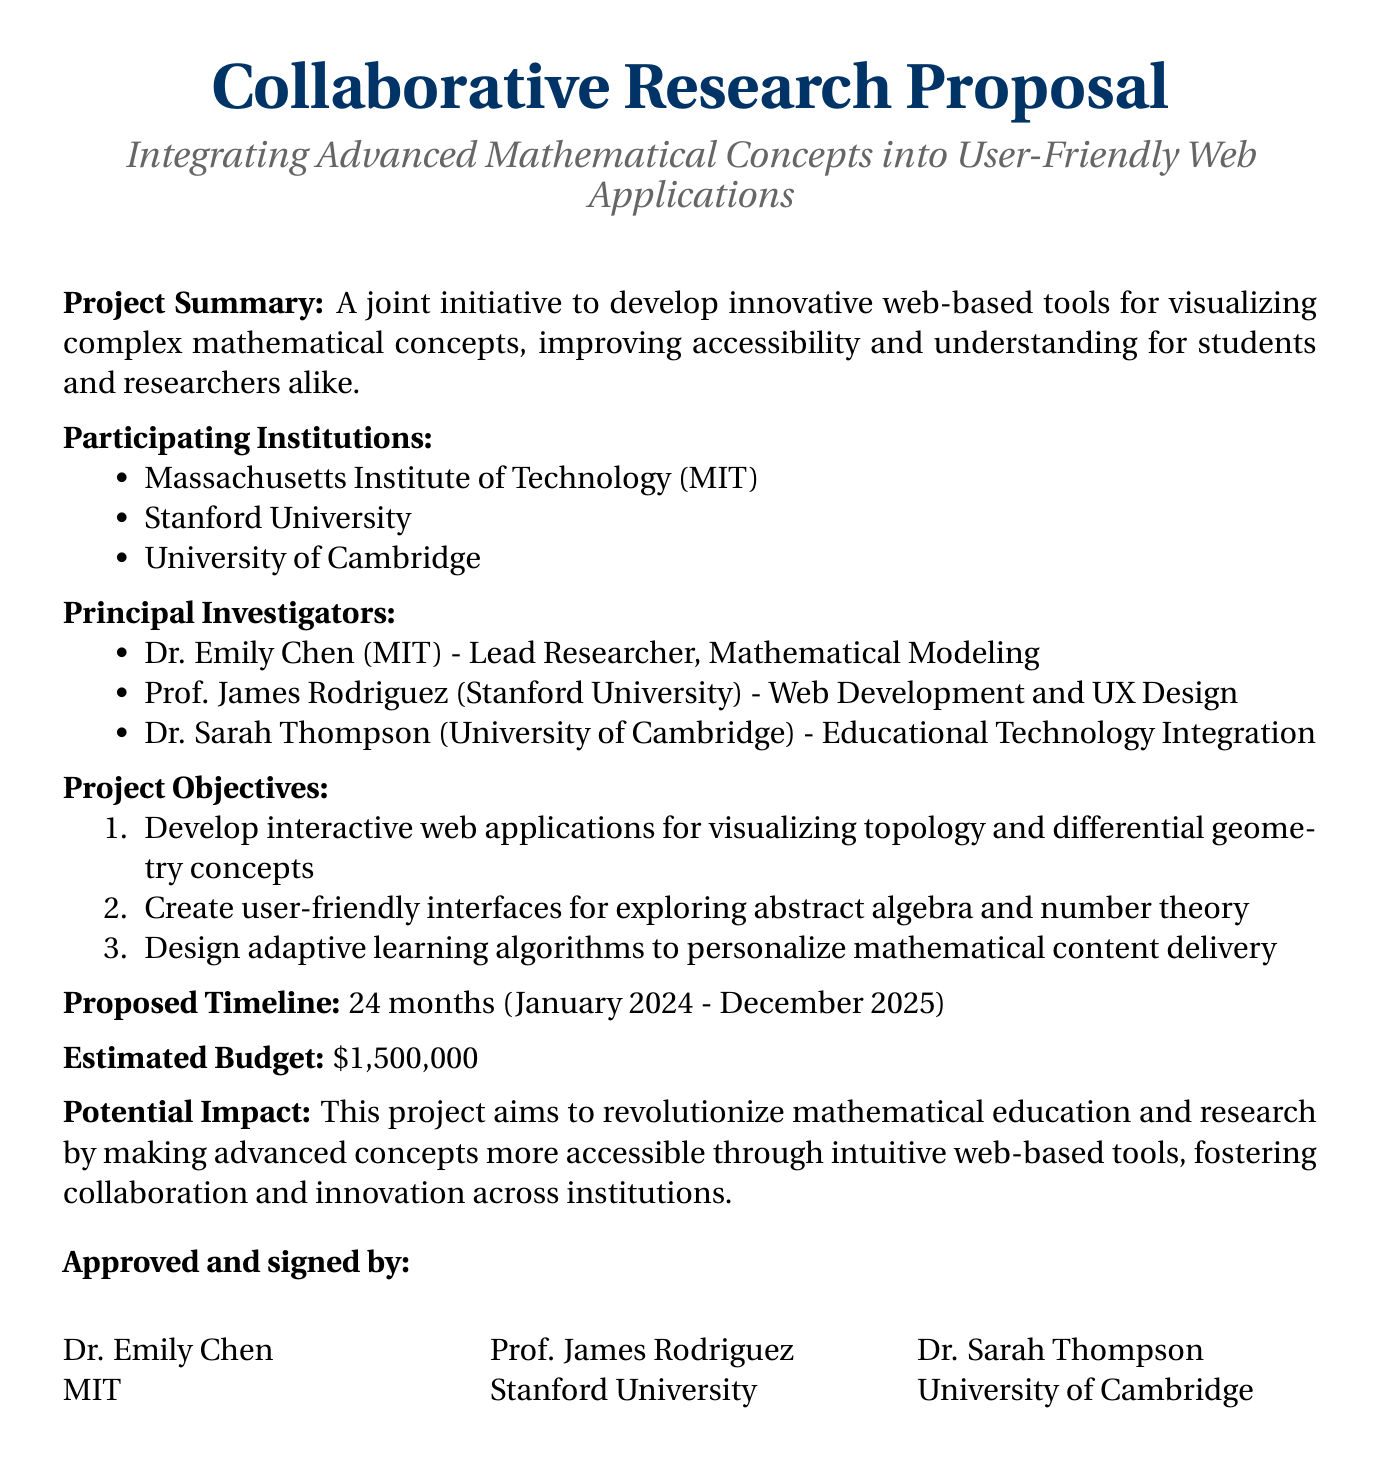What is the title of the proposal? The title of the proposal is stated clearly at the top of the document.
Answer: Collaborative Research Proposal What are the main institutions involved in the project? The document lists the participating institutions; these are MIT, Stanford University, and University of Cambridge.
Answer: MIT, Stanford University, University of Cambridge Who is the lead researcher? The document specifies Dr. Emily Chen as the lead researcher.
Answer: Dr. Emily Chen What is the estimated budget for the project? The budget amount is clearly mentioned in the document's proposed budget section.
Answer: $1,500,000 How long is the proposed timeline for the project? The timeline is specified in months in the suggested timeline section.
Answer: 24 months What mathematical concepts will be visualized through the web applications? The project objectives outline specific concepts to be visualized, which require combining information from multiple points.
Answer: Topology and differential geometry Which principal investigator focuses on educational technology integration? The document includes the names and areas of expertise of the principal investigators, highlighting Dr. Sarah Thompson's role.
Answer: Dr. Sarah Thompson When is the project scheduled to start? The proposed start date is indicated in the timeline section of the document.
Answer: January 2024 What is the potential impact mentioned in the document? The potential impact describes the overarching goals of the project as outlined in the document.
Answer: Revolutionize mathematical education and research 